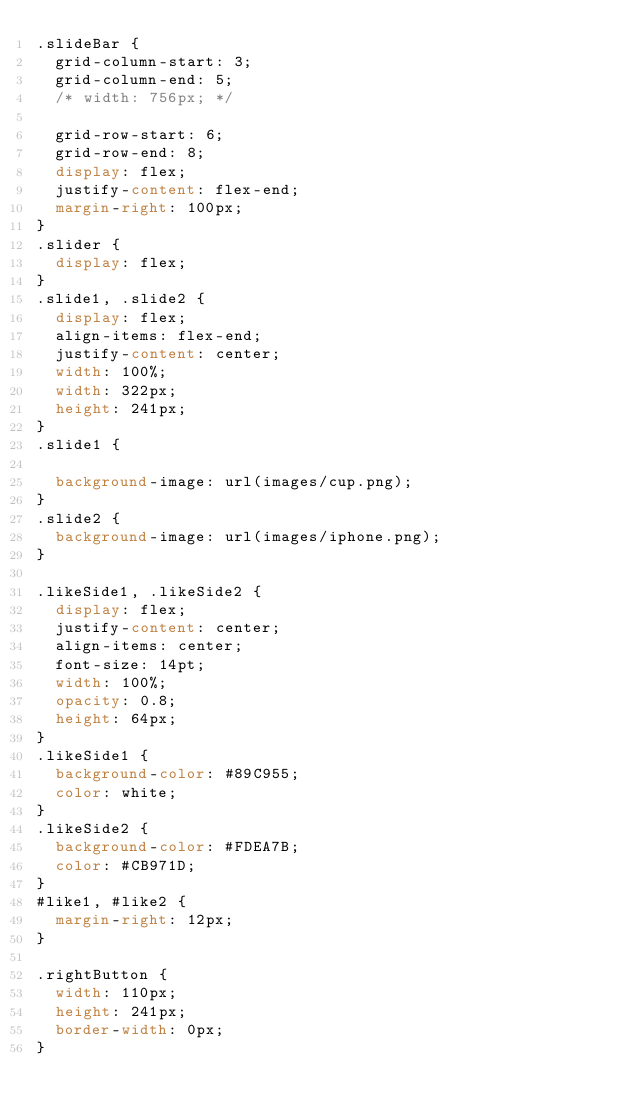Convert code to text. <code><loc_0><loc_0><loc_500><loc_500><_CSS_>.slideBar {
  grid-column-start: 3;
  grid-column-end: 5;
  /* width: 756px; */

  grid-row-start: 6;
  grid-row-end: 8;
  display: flex;
  justify-content: flex-end;
  margin-right: 100px;
}
.slider {
  display: flex;
}
.slide1, .slide2 {
  display: flex;
  align-items: flex-end;
  justify-content: center;
  width: 100%;
  width: 322px;
  height: 241px;
}
.slide1 {

  background-image: url(images/cup.png);
}
.slide2 {
  background-image: url(images/iphone.png);
}

.likeSide1, .likeSide2 {
  display: flex;
  justify-content: center;
  align-items: center;
  font-size: 14pt;
  width: 100%;
  opacity: 0.8;
  height: 64px;
}
.likeSide1 {
  background-color: #89C955;
  color: white;
}
.likeSide2 {
  background-color: #FDEA7B;
  color: #CB971D;
}
#like1, #like2 {
  margin-right: 12px;
}

.rightButton {
  width: 110px;
  height: 241px;
  border-width: 0px;
}
</code> 